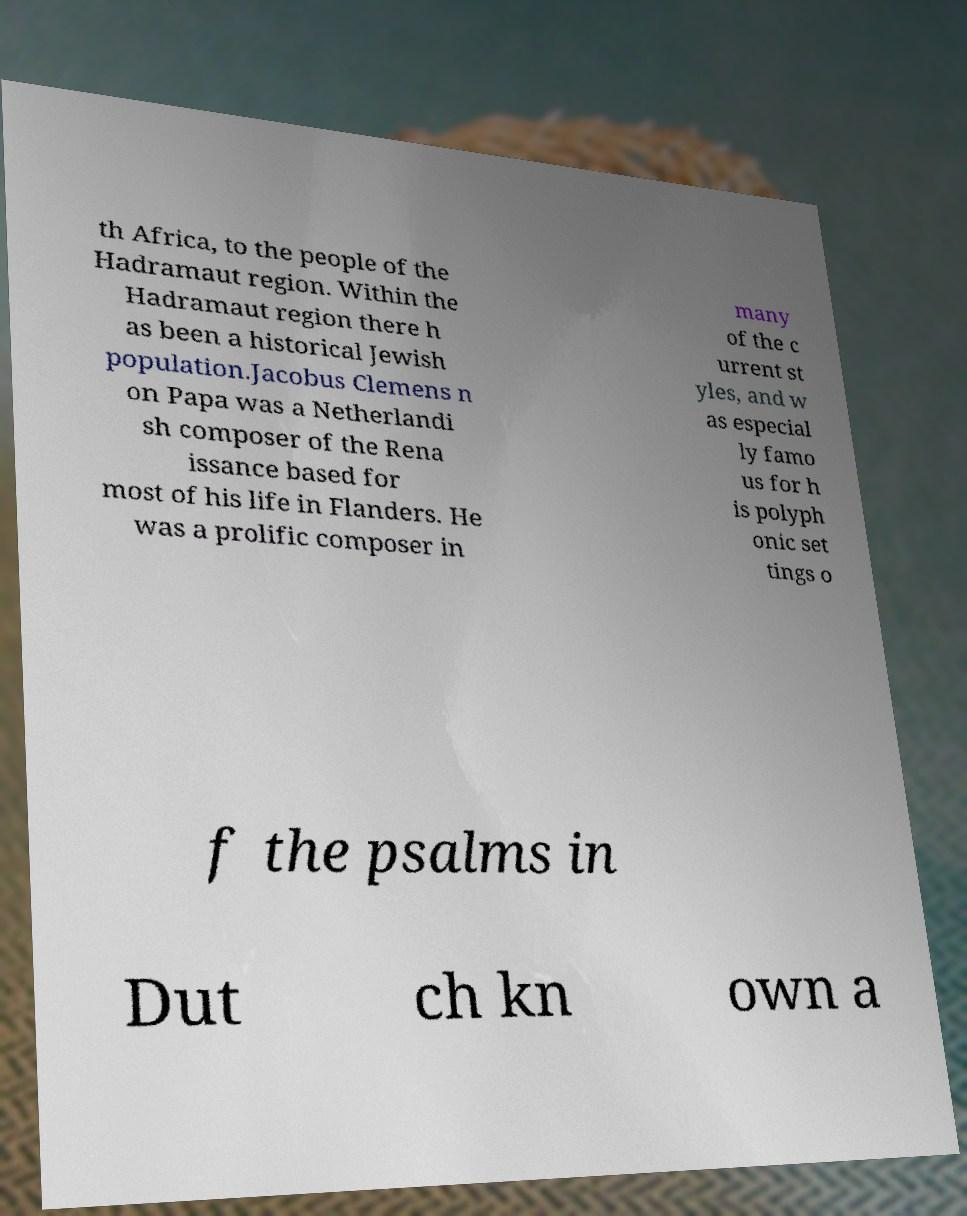I need the written content from this picture converted into text. Can you do that? th Africa, to the people of the Hadramaut region. Within the Hadramaut region there h as been a historical Jewish population.Jacobus Clemens n on Papa was a Netherlandi sh composer of the Rena issance based for most of his life in Flanders. He was a prolific composer in many of the c urrent st yles, and w as especial ly famo us for h is polyph onic set tings o f the psalms in Dut ch kn own a 